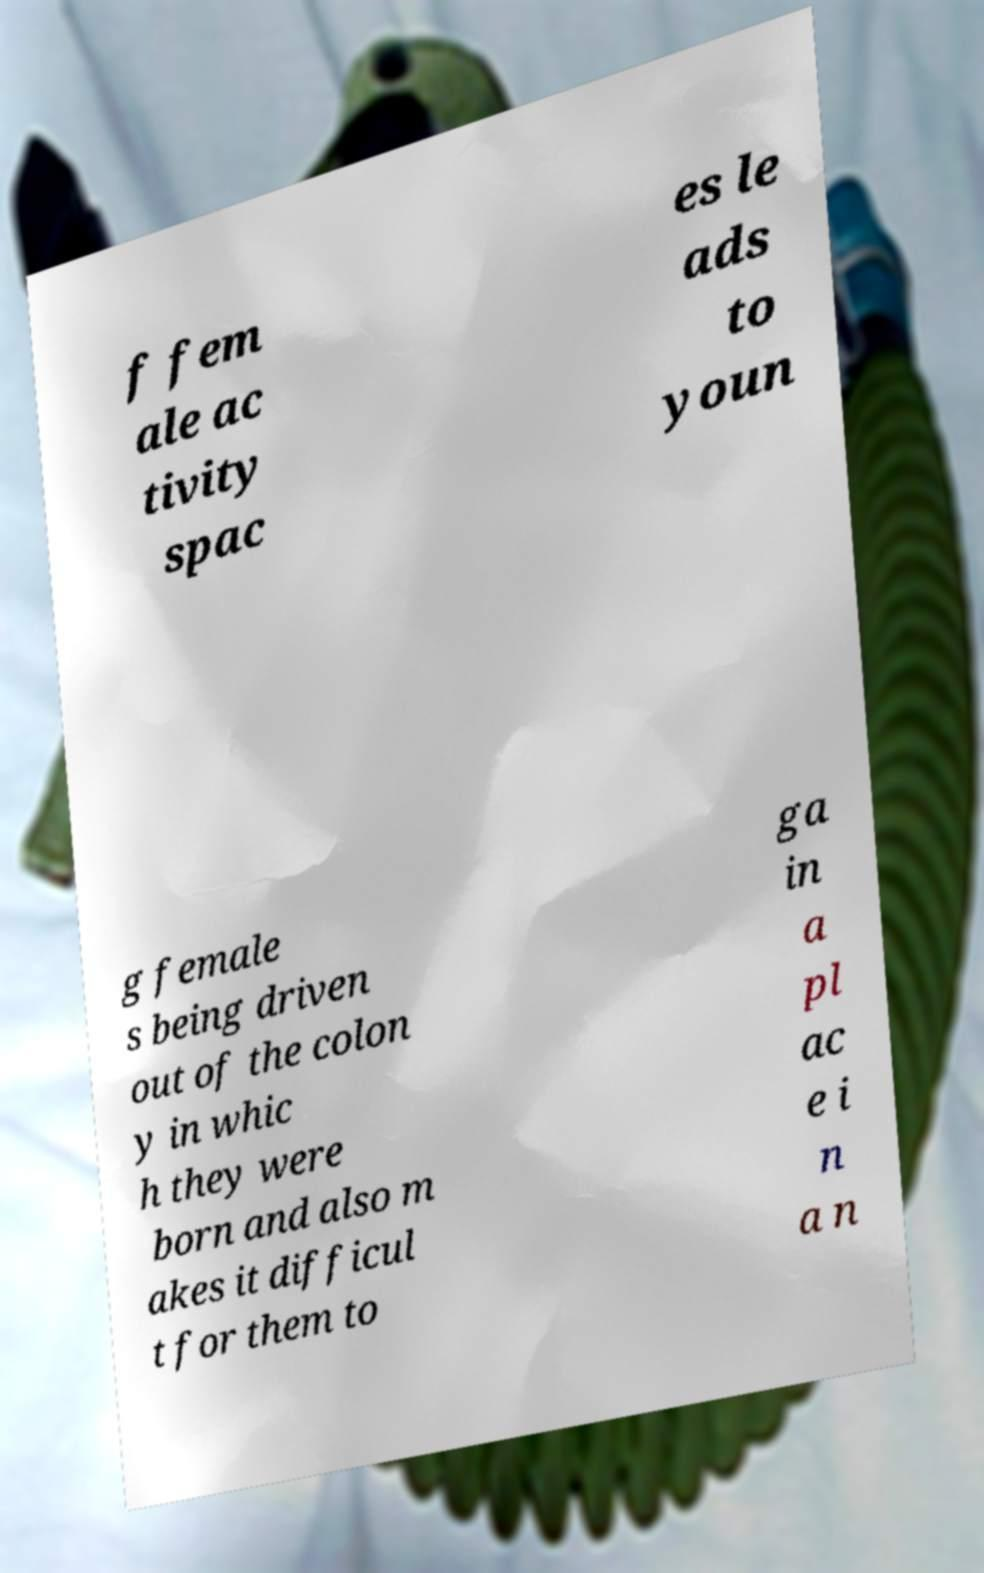I need the written content from this picture converted into text. Can you do that? f fem ale ac tivity spac es le ads to youn g female s being driven out of the colon y in whic h they were born and also m akes it difficul t for them to ga in a pl ac e i n a n 